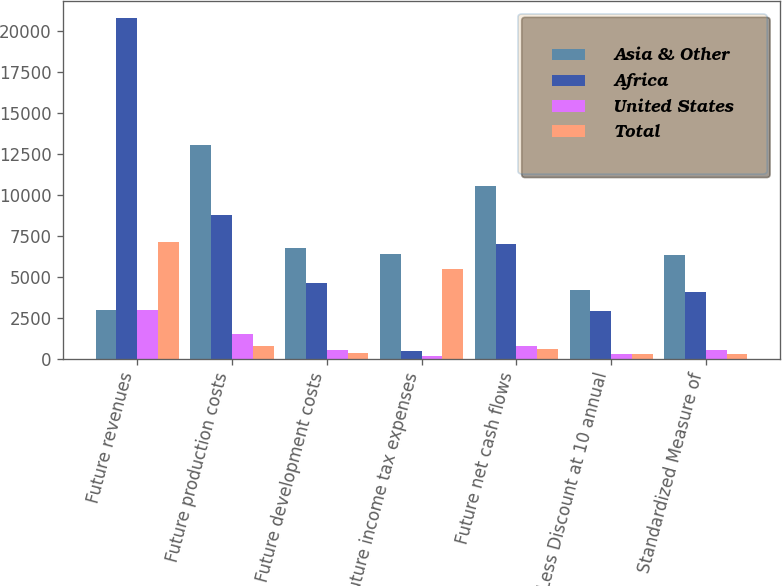Convert chart to OTSL. <chart><loc_0><loc_0><loc_500><loc_500><stacked_bar_chart><ecel><fcel>Future revenues<fcel>Future production costs<fcel>Future development costs<fcel>Future income tax expenses<fcel>Future net cash flows<fcel>Less Discount at 10 annual<fcel>Standardized Measure of<nl><fcel>Asia & Other<fcel>2958<fcel>13042<fcel>6748<fcel>6379<fcel>10577<fcel>4221<fcel>6356<nl><fcel>Africa<fcel>20834<fcel>8802<fcel>4601<fcel>444<fcel>6987<fcel>2904<fcel>4083<nl><fcel>United States<fcel>2958<fcel>1501<fcel>553<fcel>137<fcel>767<fcel>272<fcel>495<nl><fcel>Total<fcel>7154<fcel>782<fcel>330<fcel>5485<fcel>557<fcel>307<fcel>250<nl></chart> 